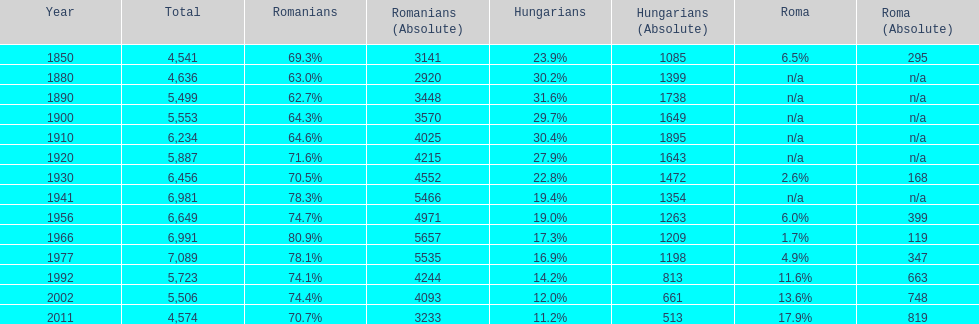What year had the next highest percentage for roma after 2011? 2002. 